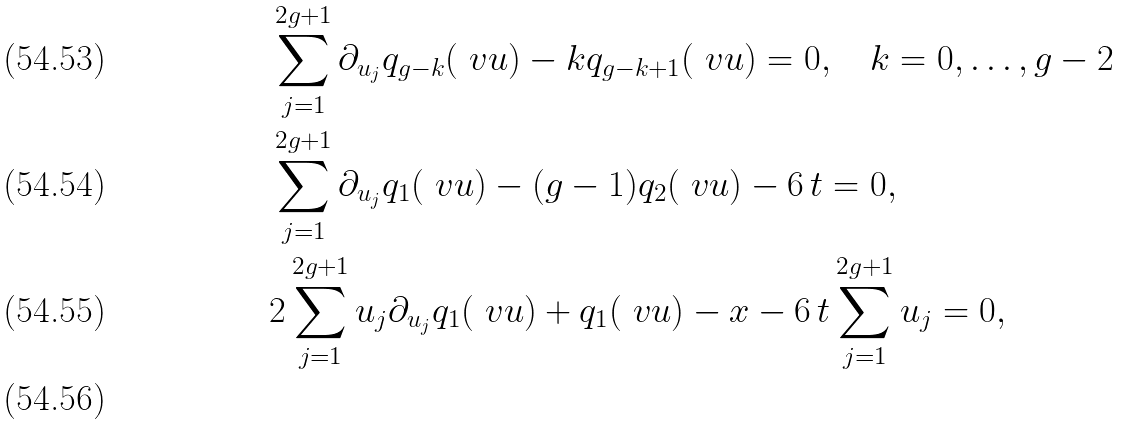Convert formula to latex. <formula><loc_0><loc_0><loc_500><loc_500>& \sum _ { j = 1 } ^ { 2 g + 1 } \partial _ { u _ { j } } q _ { g - k } ( \ v u ) - k q _ { g - k + 1 } ( \ v u ) = 0 , \quad k = 0 , \dots , g - 2 \\ & \sum _ { j = 1 } ^ { 2 g + 1 } \partial _ { u _ { j } } q _ { 1 } ( \ v u ) - ( g - 1 ) q _ { 2 } ( \ v u ) - 6 \, t = 0 , \\ & 2 \sum _ { j = 1 } ^ { 2 g + 1 } u _ { j } \partial _ { u _ { j } } q _ { 1 } ( \ v u ) + q _ { 1 } ( \ v u ) - x - 6 \, t \sum _ { j = 1 } ^ { 2 g + 1 } u _ { j } = 0 , \\</formula> 